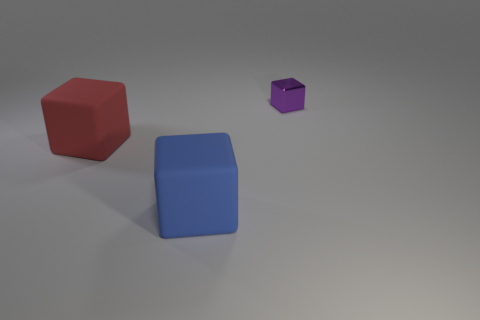Subtract all big red blocks. How many blocks are left? 2 Add 2 red things. How many objects exist? 5 Subtract all blue cubes. How many cubes are left? 2 Subtract 1 blocks. How many blocks are left? 2 Subtract all green balls. How many green blocks are left? 0 Subtract all large blue rubber things. Subtract all red blocks. How many objects are left? 1 Add 2 tiny metallic blocks. How many tiny metallic blocks are left? 3 Add 3 small cyan cubes. How many small cyan cubes exist? 3 Subtract 0 gray balls. How many objects are left? 3 Subtract all gray blocks. Subtract all red balls. How many blocks are left? 3 